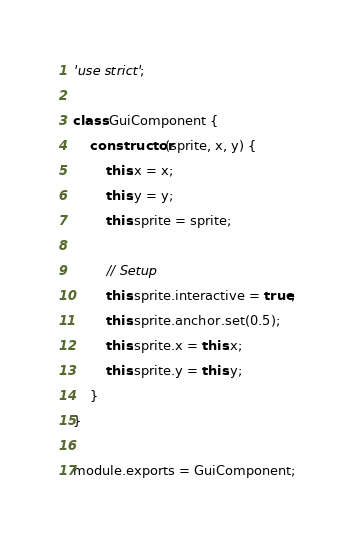Convert code to text. <code><loc_0><loc_0><loc_500><loc_500><_JavaScript_>'use strict';

class GuiComponent {
    constructor(sprite, x, y) {
        this.x = x;
        this.y = y;
        this.sprite = sprite;

        // Setup
        this.sprite.interactive = true;
        this.sprite.anchor.set(0.5);
        this.sprite.x = this.x;
        this.sprite.y = this.y;
    }
}

module.exports = GuiComponent;
</code> 